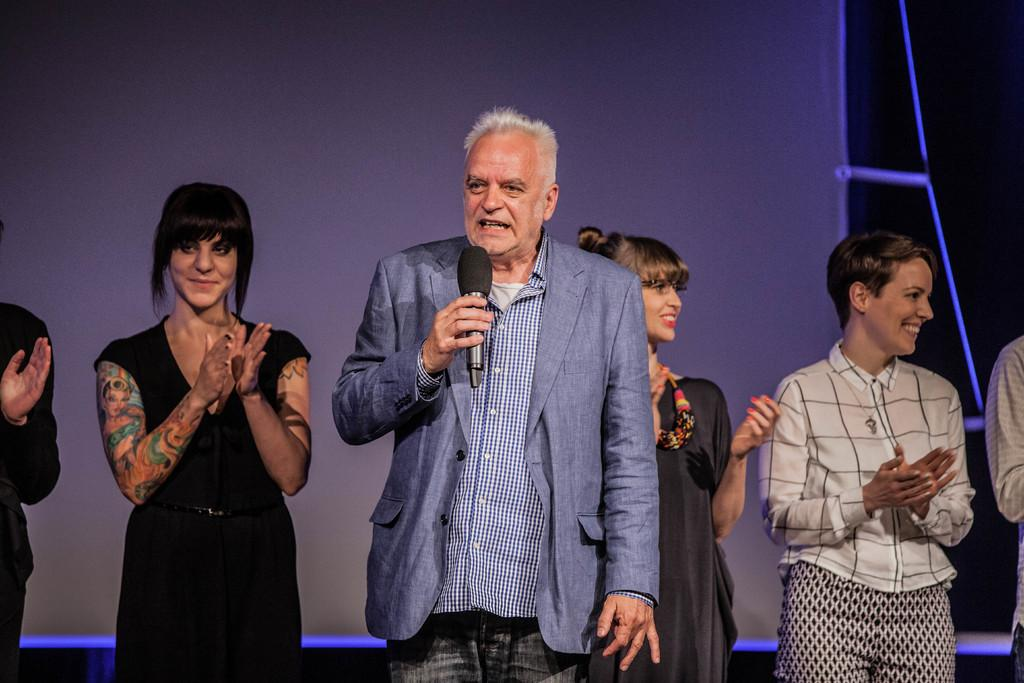What is the man in the image doing? The man is standing and speaking in front of a microphone. What are the people in the image doing? The people are clapping their hands and smiling. Can you describe the man's activity in more detail? The man is likely giving a speech or presentation, as he is speaking into a microphone. What type of tray is being used by the zebra in the image? There is no zebra or tray present in the image. 